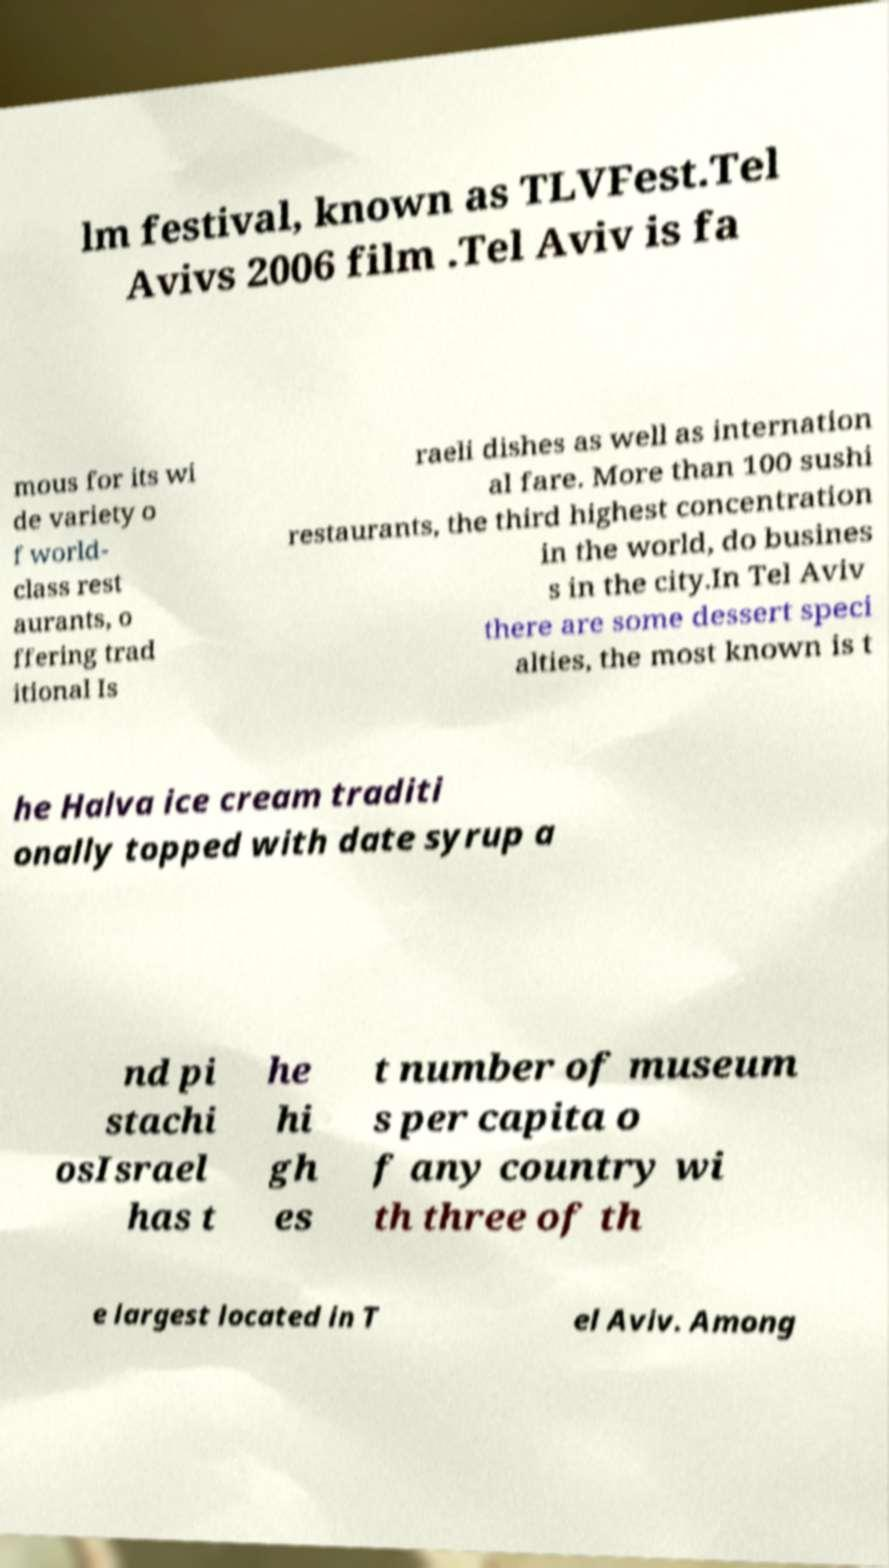Could you assist in decoding the text presented in this image and type it out clearly? lm festival, known as TLVFest.Tel Avivs 2006 film .Tel Aviv is fa mous for its wi de variety o f world- class rest aurants, o ffering trad itional Is raeli dishes as well as internation al fare. More than 100 sushi restaurants, the third highest concentration in the world, do busines s in the city.In Tel Aviv there are some dessert speci alties, the most known is t he Halva ice cream traditi onally topped with date syrup a nd pi stachi osIsrael has t he hi gh es t number of museum s per capita o f any country wi th three of th e largest located in T el Aviv. Among 